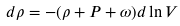Convert formula to latex. <formula><loc_0><loc_0><loc_500><loc_500>d \rho = - ( \rho + P + \omega ) d \ln V</formula> 